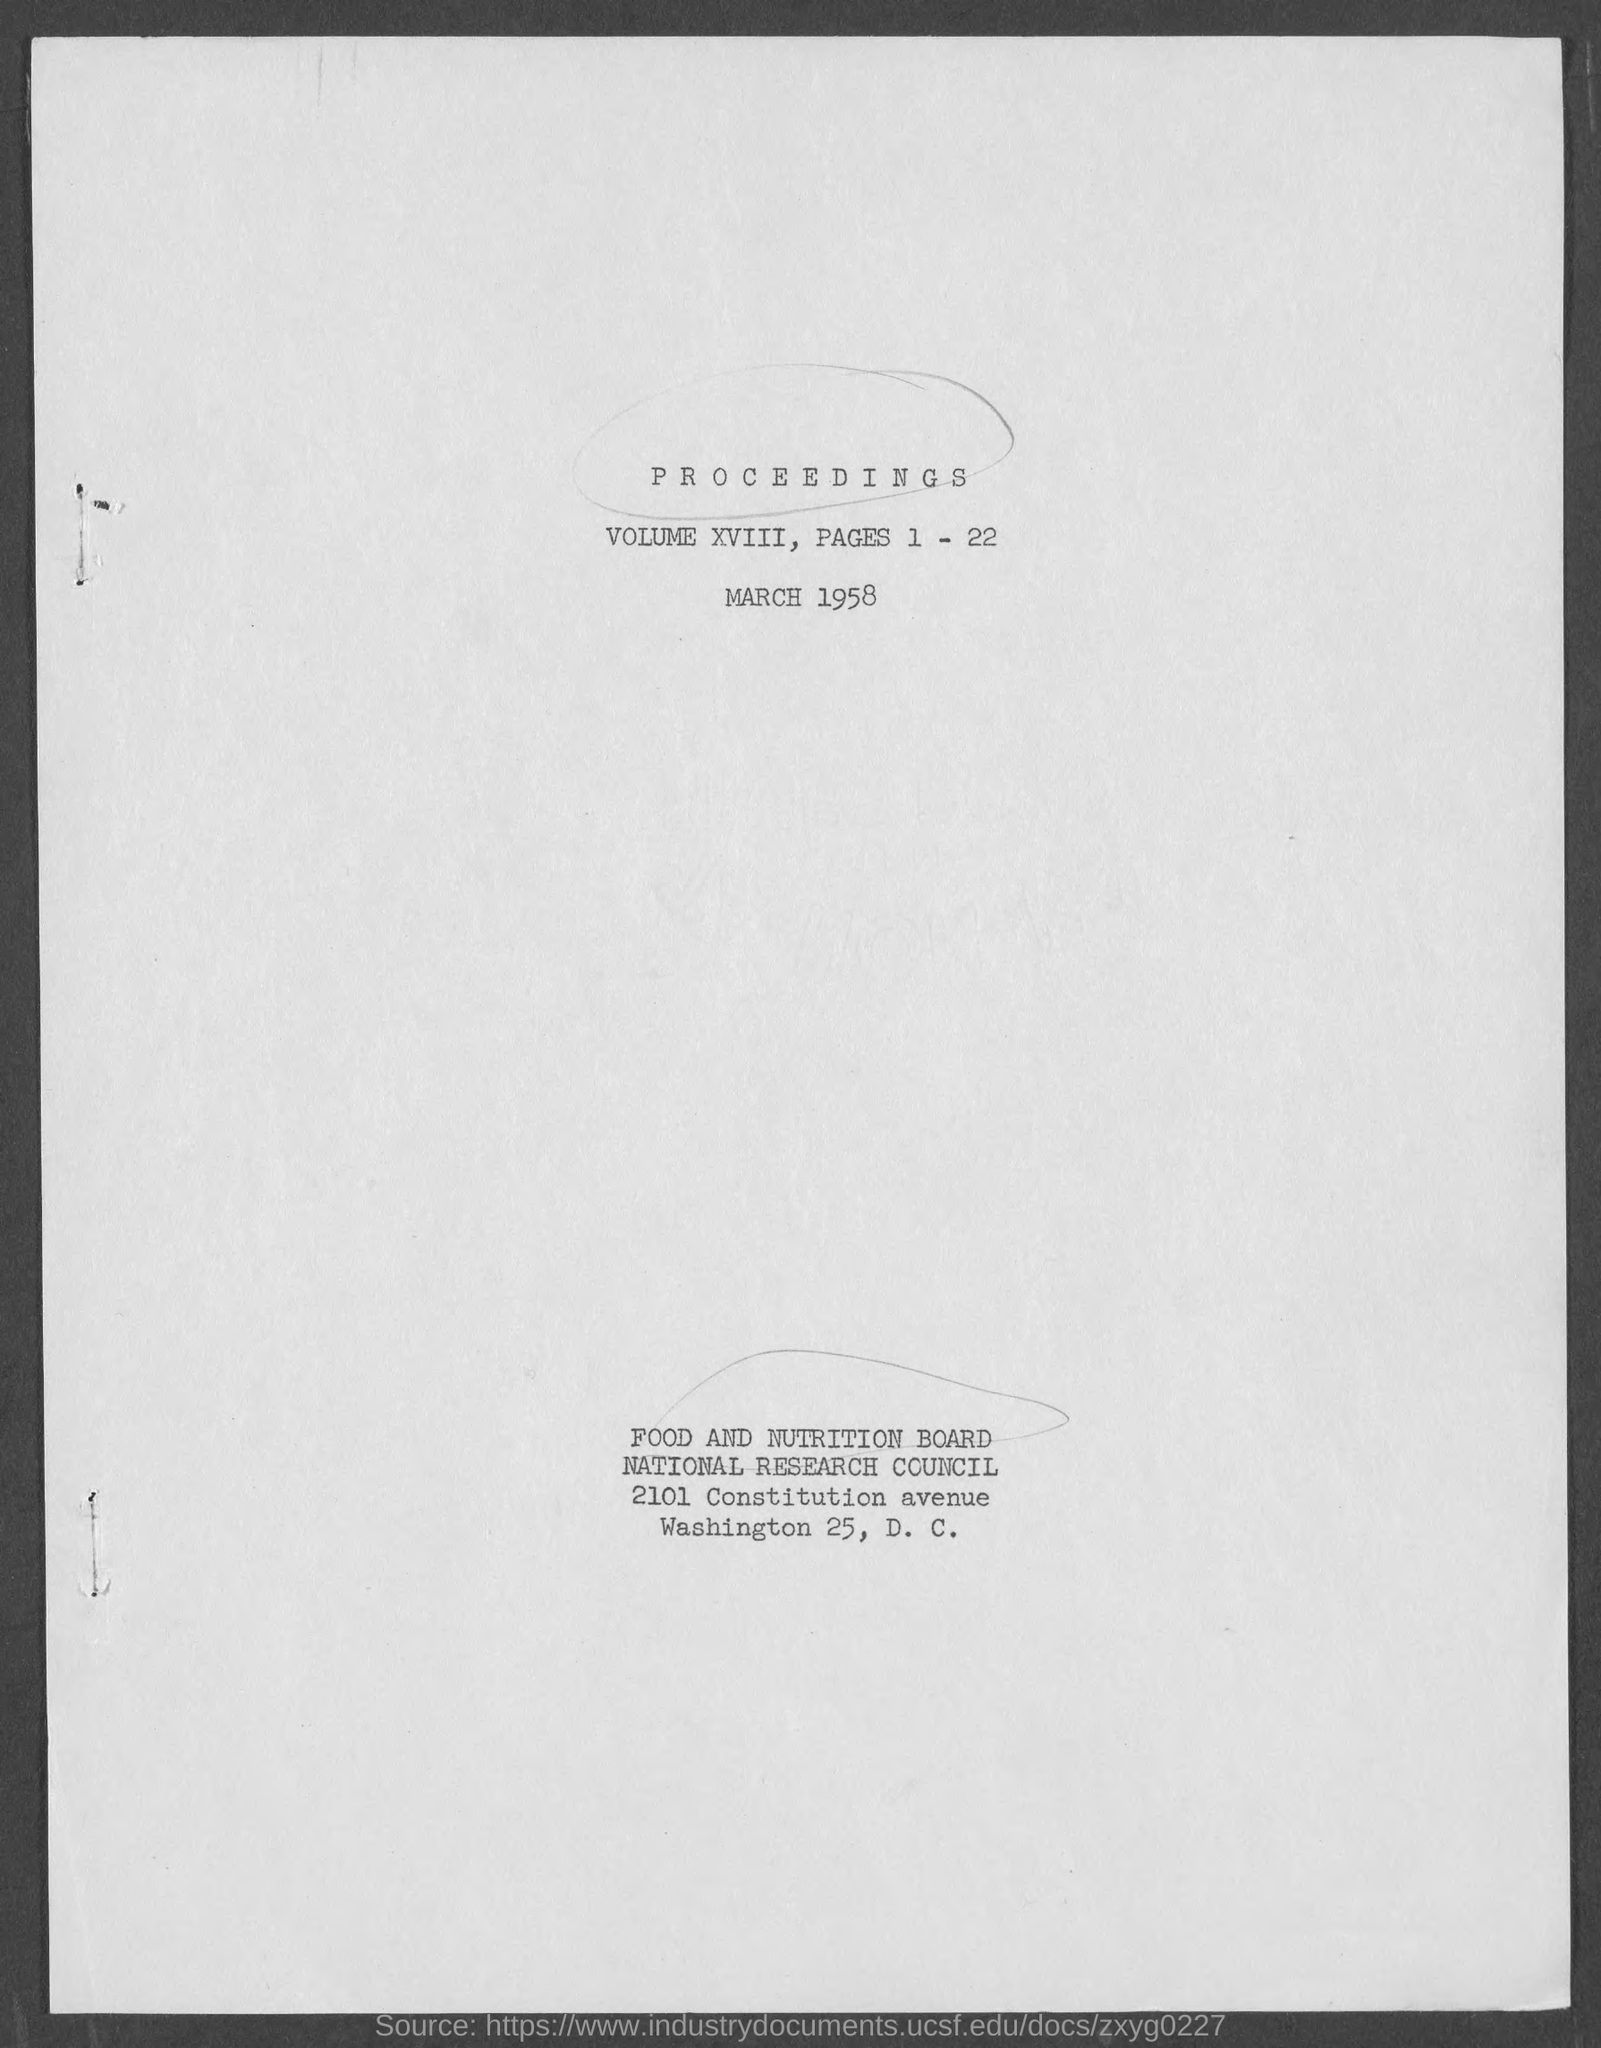Outline some significant characteristics in this image. The volume number is XVIII. The Volume was issued in March 1958. Volume XVIII contains the proceedings of... 